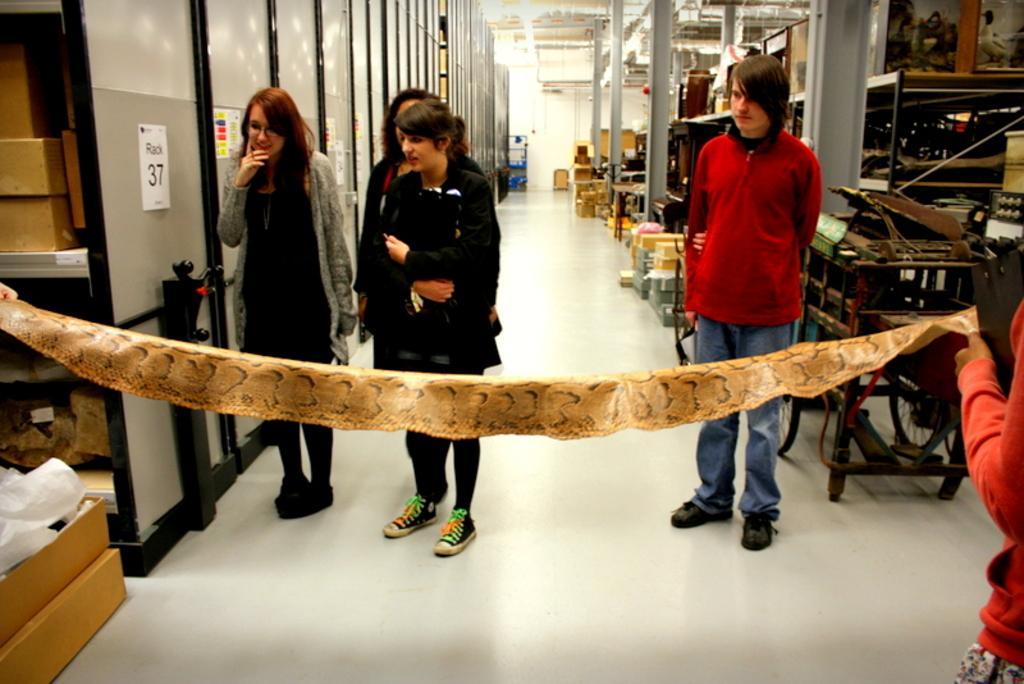How would you summarize this image in a sentence or two? In this picture, we can see there are two people holding an object and behind the object there are four people standing on the floor and on the left side of the people there are cardboard boxes and a black machine. On the right side of the people there are some objects. 